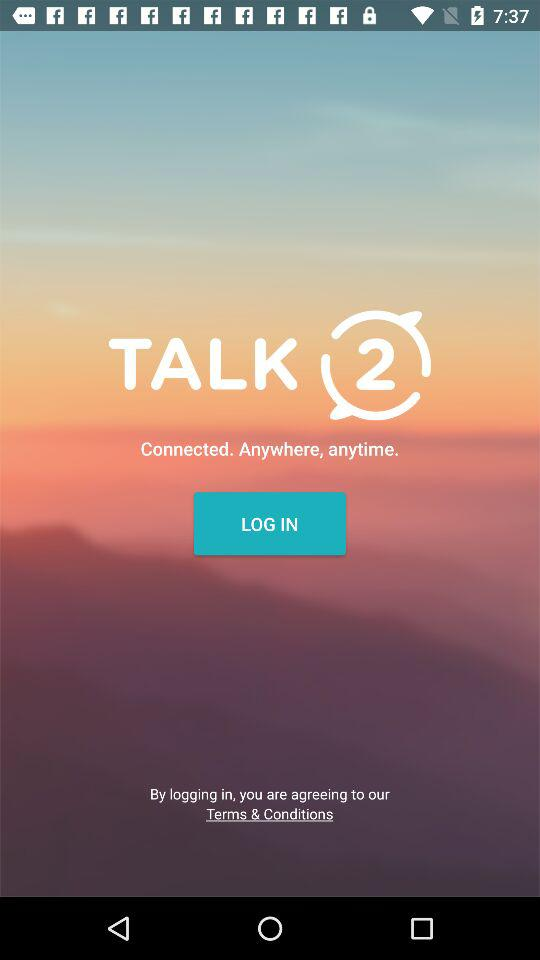What is the name of the application? The name of the application is "TALK 2". 